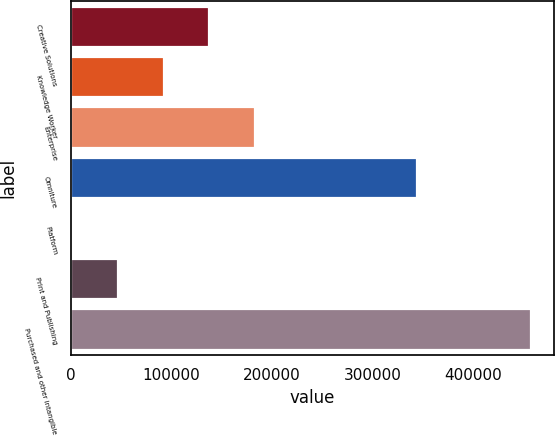Convert chart. <chart><loc_0><loc_0><loc_500><loc_500><bar_chart><fcel>Creative Solutions<fcel>Knowledge Worker<fcel>Enterprise<fcel>Omniture<fcel>Platform<fcel>Print and Publishing<fcel>Purchased and other intangible<nl><fcel>138024<fcel>92419<fcel>183630<fcel>344059<fcel>1208<fcel>46813.5<fcel>457263<nl></chart> 